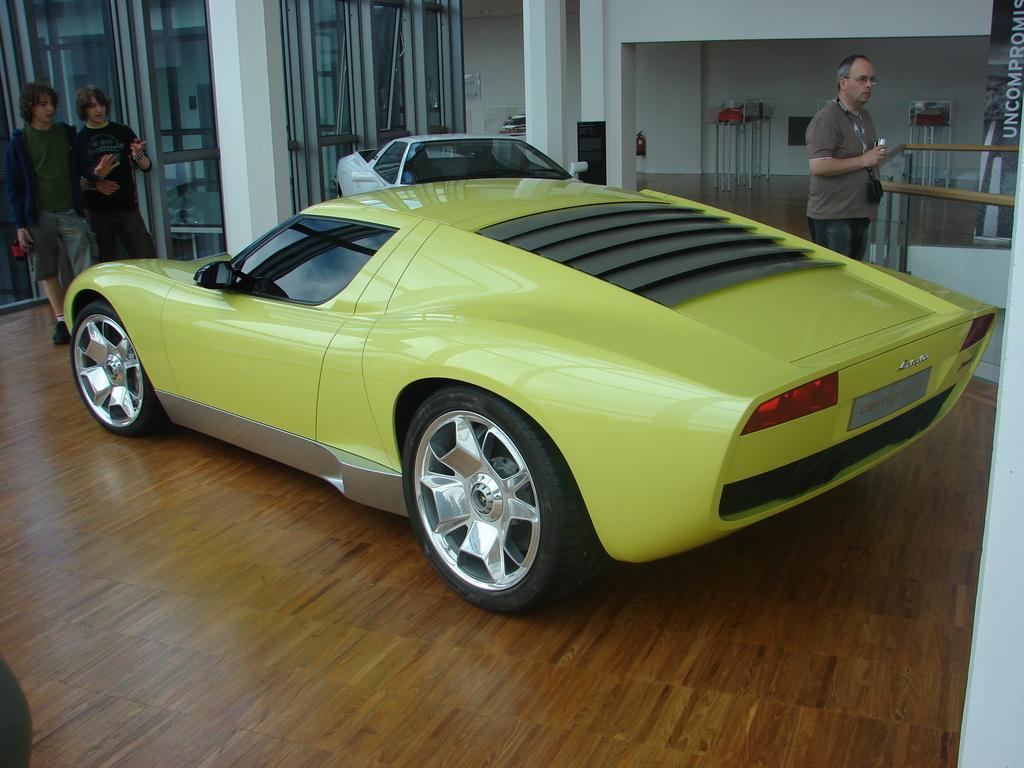In one or two sentences, can you explain what this image depicts? In this picture we can see two cars and three people standing on the floor and in the background we can see pillars, walls, poster and some objects. 